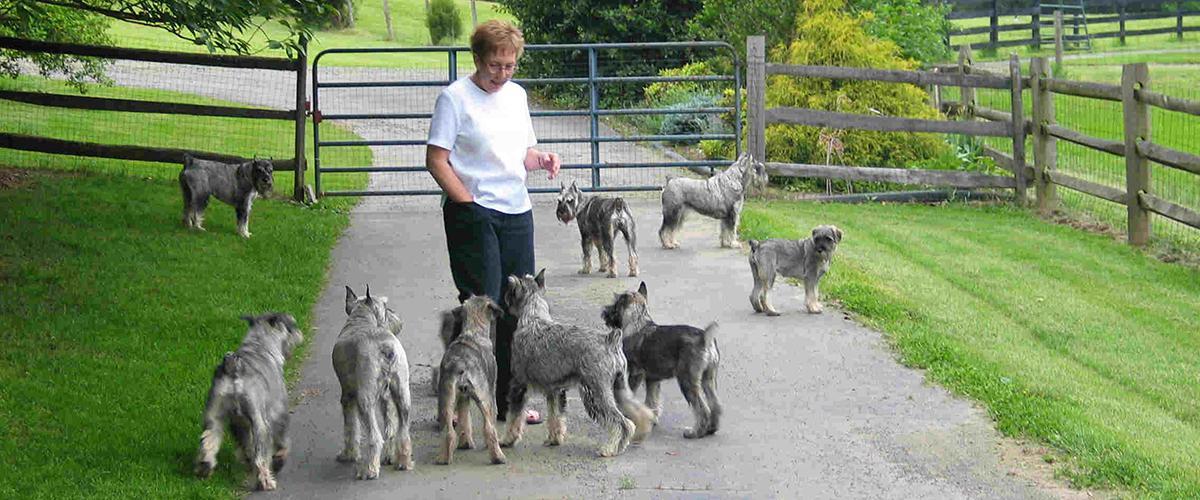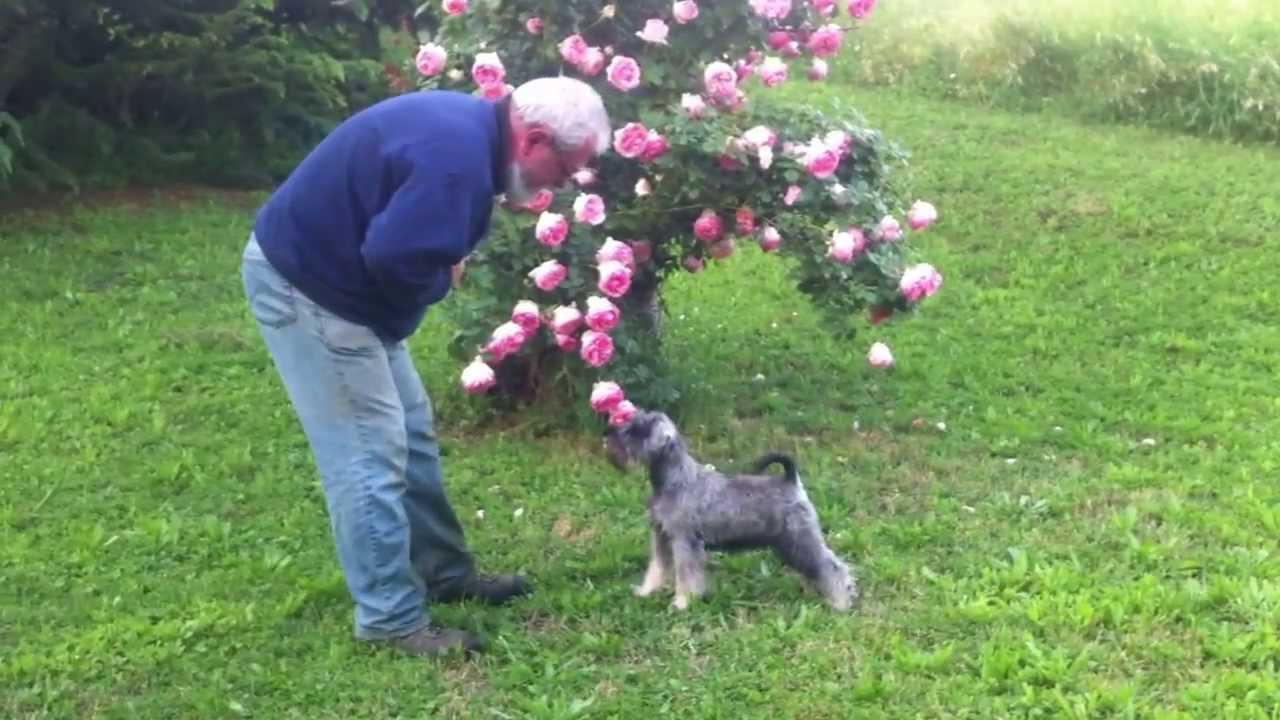The first image is the image on the left, the second image is the image on the right. For the images displayed, is the sentence "An image shows one schnauzer in the grass, with planted blooming flowers behind the dog but not in front of it." factually correct? Answer yes or no. Yes. The first image is the image on the left, the second image is the image on the right. Evaluate the accuracy of this statement regarding the images: "A person is standing with a group of dogs in the image on the left.". Is it true? Answer yes or no. Yes. 